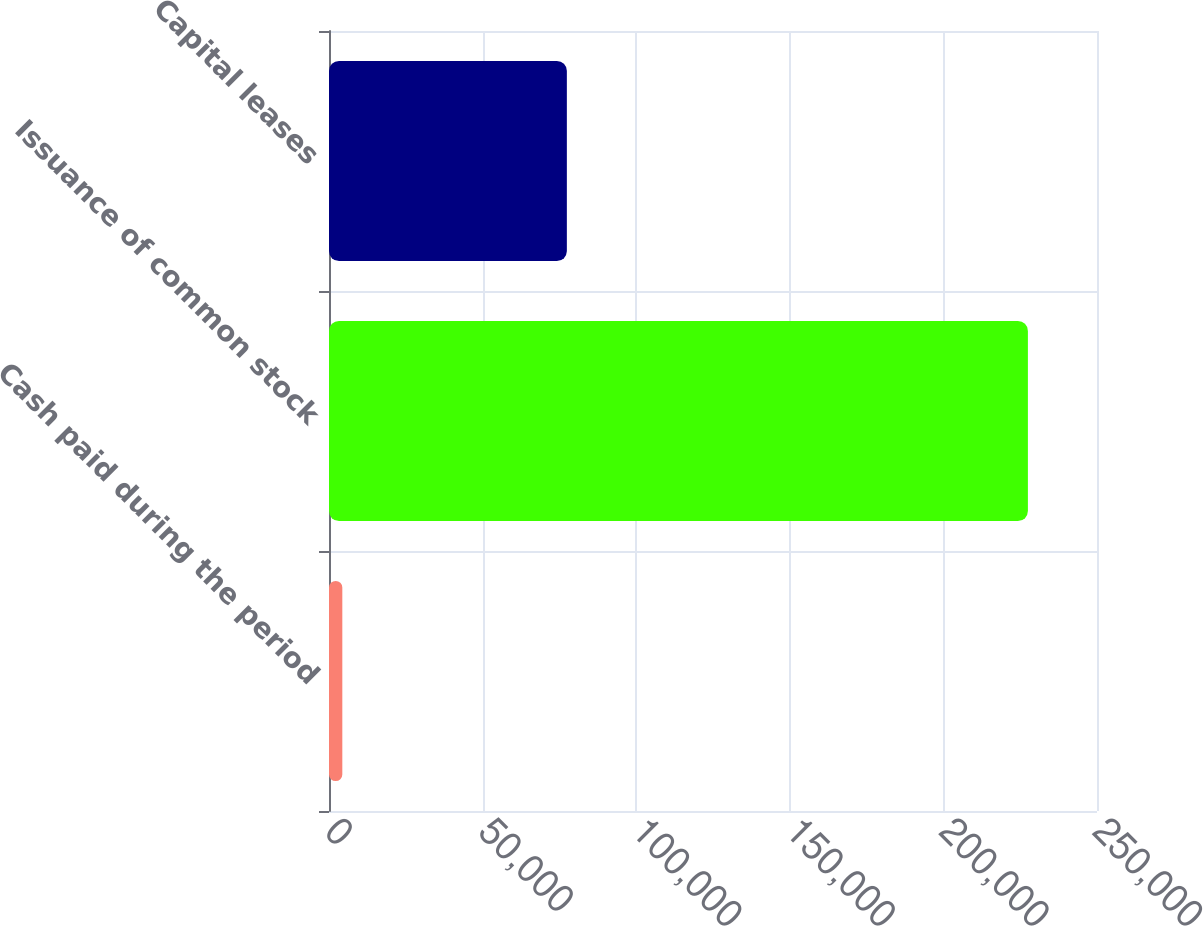<chart> <loc_0><loc_0><loc_500><loc_500><bar_chart><fcel>Cash paid during the period<fcel>Issuance of common stock<fcel>Capital leases<nl><fcel>4335<fcel>227507<fcel>77427<nl></chart> 